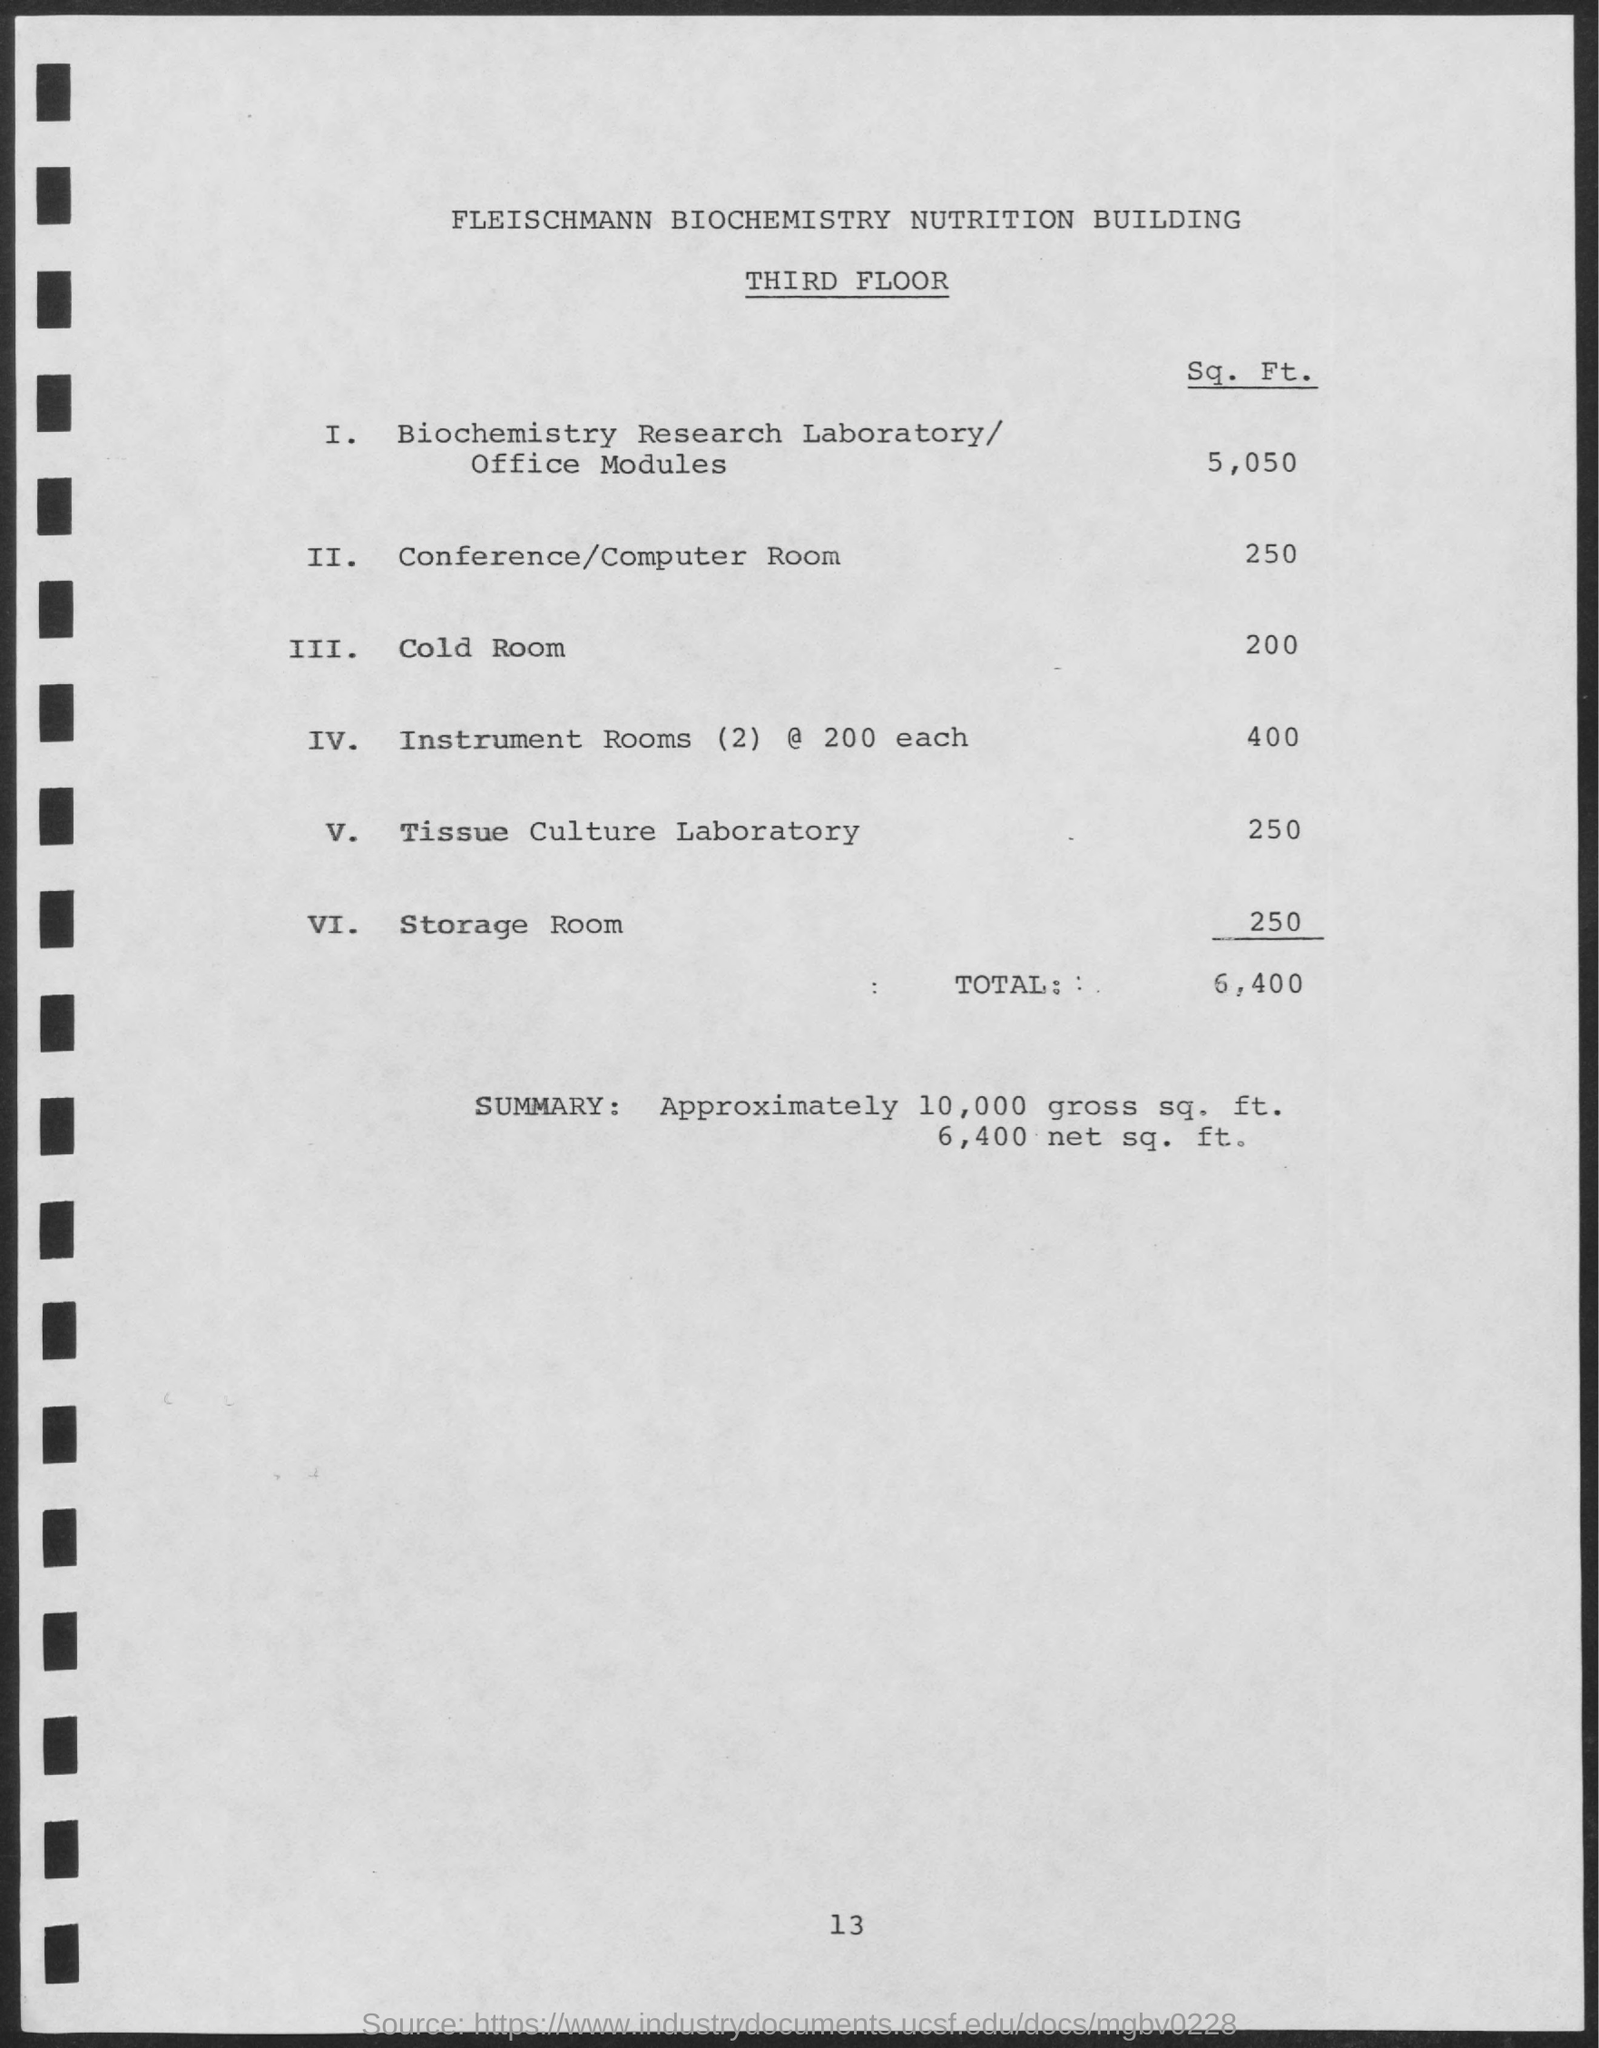Draw attention to some important aspects in this diagram. The third floor is mentioned. The gross square footage of the property is approximately 10,000 square feet. The cost per square foot for a cold room is approximately 200. The building being referred to is named the Fleischmann Biochemistry and Nutrition Building. The square footage of the property is 6,400 square feet. 